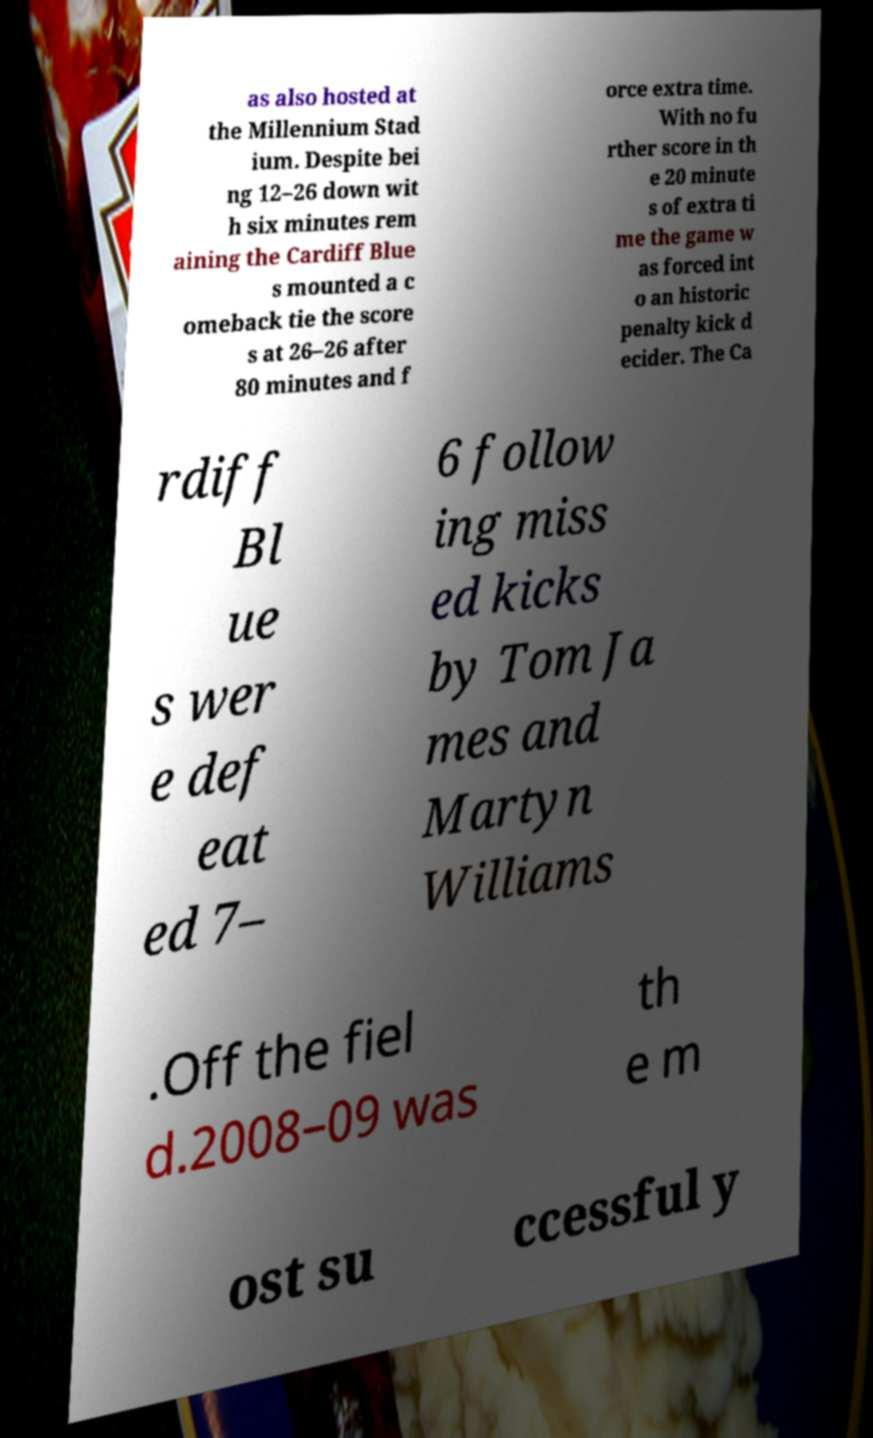There's text embedded in this image that I need extracted. Can you transcribe it verbatim? as also hosted at the Millennium Stad ium. Despite bei ng 12–26 down wit h six minutes rem aining the Cardiff Blue s mounted a c omeback tie the score s at 26–26 after 80 minutes and f orce extra time. With no fu rther score in th e 20 minute s of extra ti me the game w as forced int o an historic penalty kick d ecider. The Ca rdiff Bl ue s wer e def eat ed 7– 6 follow ing miss ed kicks by Tom Ja mes and Martyn Williams .Off the fiel d.2008–09 was th e m ost su ccessful y 